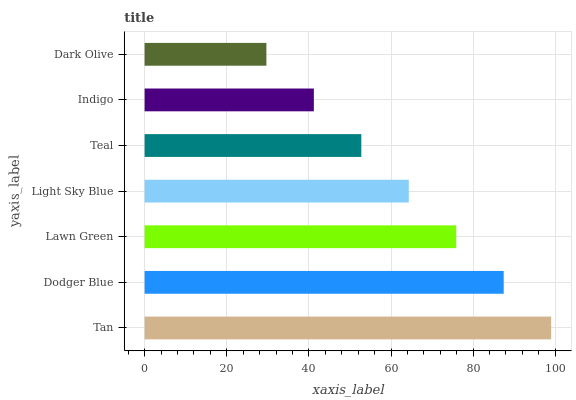Is Dark Olive the minimum?
Answer yes or no. Yes. Is Tan the maximum?
Answer yes or no. Yes. Is Dodger Blue the minimum?
Answer yes or no. No. Is Dodger Blue the maximum?
Answer yes or no. No. Is Tan greater than Dodger Blue?
Answer yes or no. Yes. Is Dodger Blue less than Tan?
Answer yes or no. Yes. Is Dodger Blue greater than Tan?
Answer yes or no. No. Is Tan less than Dodger Blue?
Answer yes or no. No. Is Light Sky Blue the high median?
Answer yes or no. Yes. Is Light Sky Blue the low median?
Answer yes or no. Yes. Is Dodger Blue the high median?
Answer yes or no. No. Is Dodger Blue the low median?
Answer yes or no. No. 